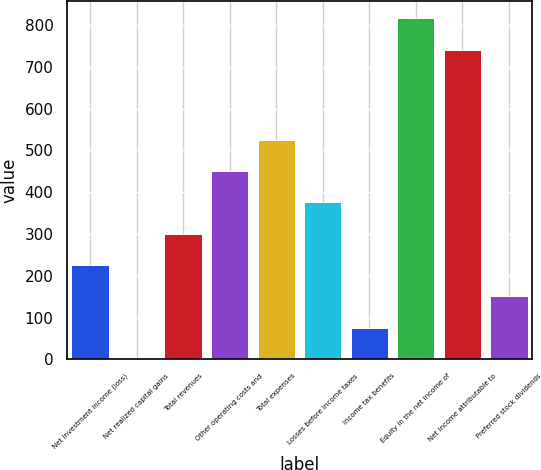Convert chart. <chart><loc_0><loc_0><loc_500><loc_500><bar_chart><fcel>Net investment income (loss)<fcel>Net realized capital gains<fcel>Total revenues<fcel>Other operating costs and<fcel>Total expenses<fcel>Losses before income taxes<fcel>Income tax benefits<fcel>Equity in the net income of<fcel>Net income attributable to<fcel>Preferred stock dividends<nl><fcel>225.7<fcel>0.7<fcel>300.7<fcel>450.7<fcel>525.7<fcel>375.7<fcel>75.7<fcel>816.3<fcel>741.3<fcel>150.7<nl></chart> 